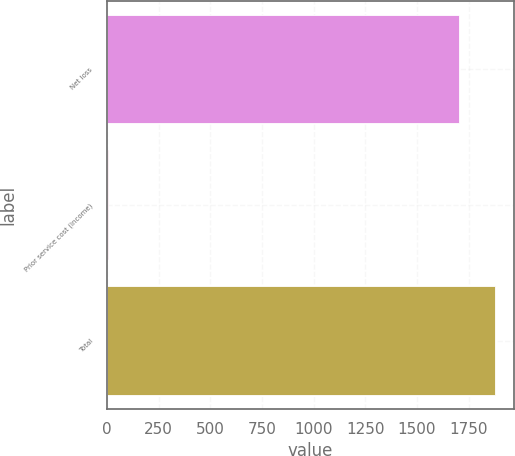Convert chart to OTSL. <chart><loc_0><loc_0><loc_500><loc_500><bar_chart><fcel>Net loss<fcel>Prior service cost (income)<fcel>Total<nl><fcel>1705<fcel>3<fcel>1875.5<nl></chart> 